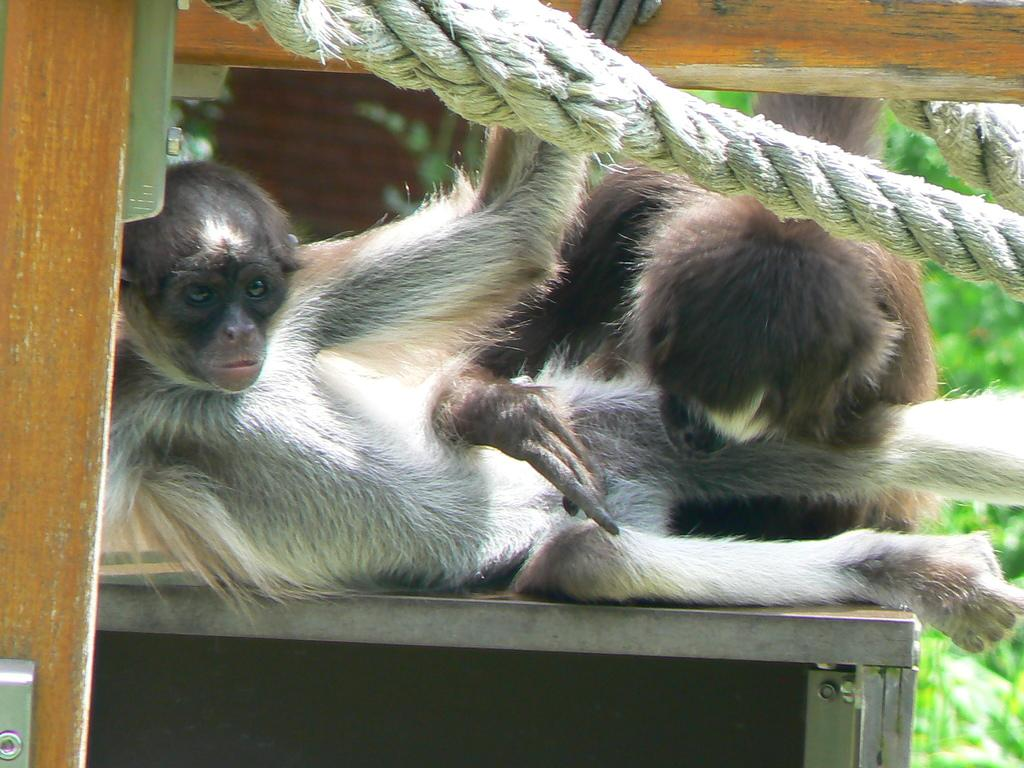What can be seen in the image in terms of living creatures? There are two animals in the image. What are the animals doing in the image? The animals are resting on an object. What additional object can be seen in the image? There is a wooden frame with a rope in the image. How would you describe the background of the image? The background of the image is blurred. What type of rice is being used as a decoration in the image? There is no rice present in the image; it features two animals resting on an object and a wooden frame with a rope. 